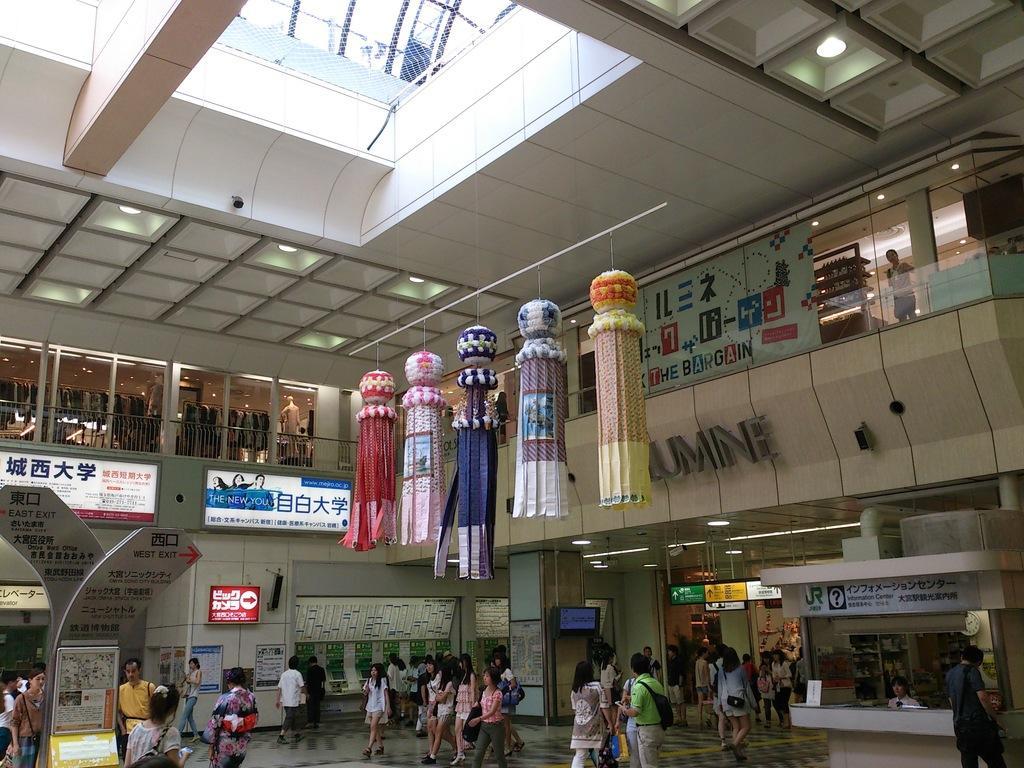Describe this image in one or two sentences. In this picture we can see an inside view of a building, there are some people walking at the bottom, on the left side there are words, we can see some text on these boards, in the background there are some stores and glasses, there is the ceiling and lights at the top of the picture, we can also see a screen in the background, there are decorative things present in the middle. 